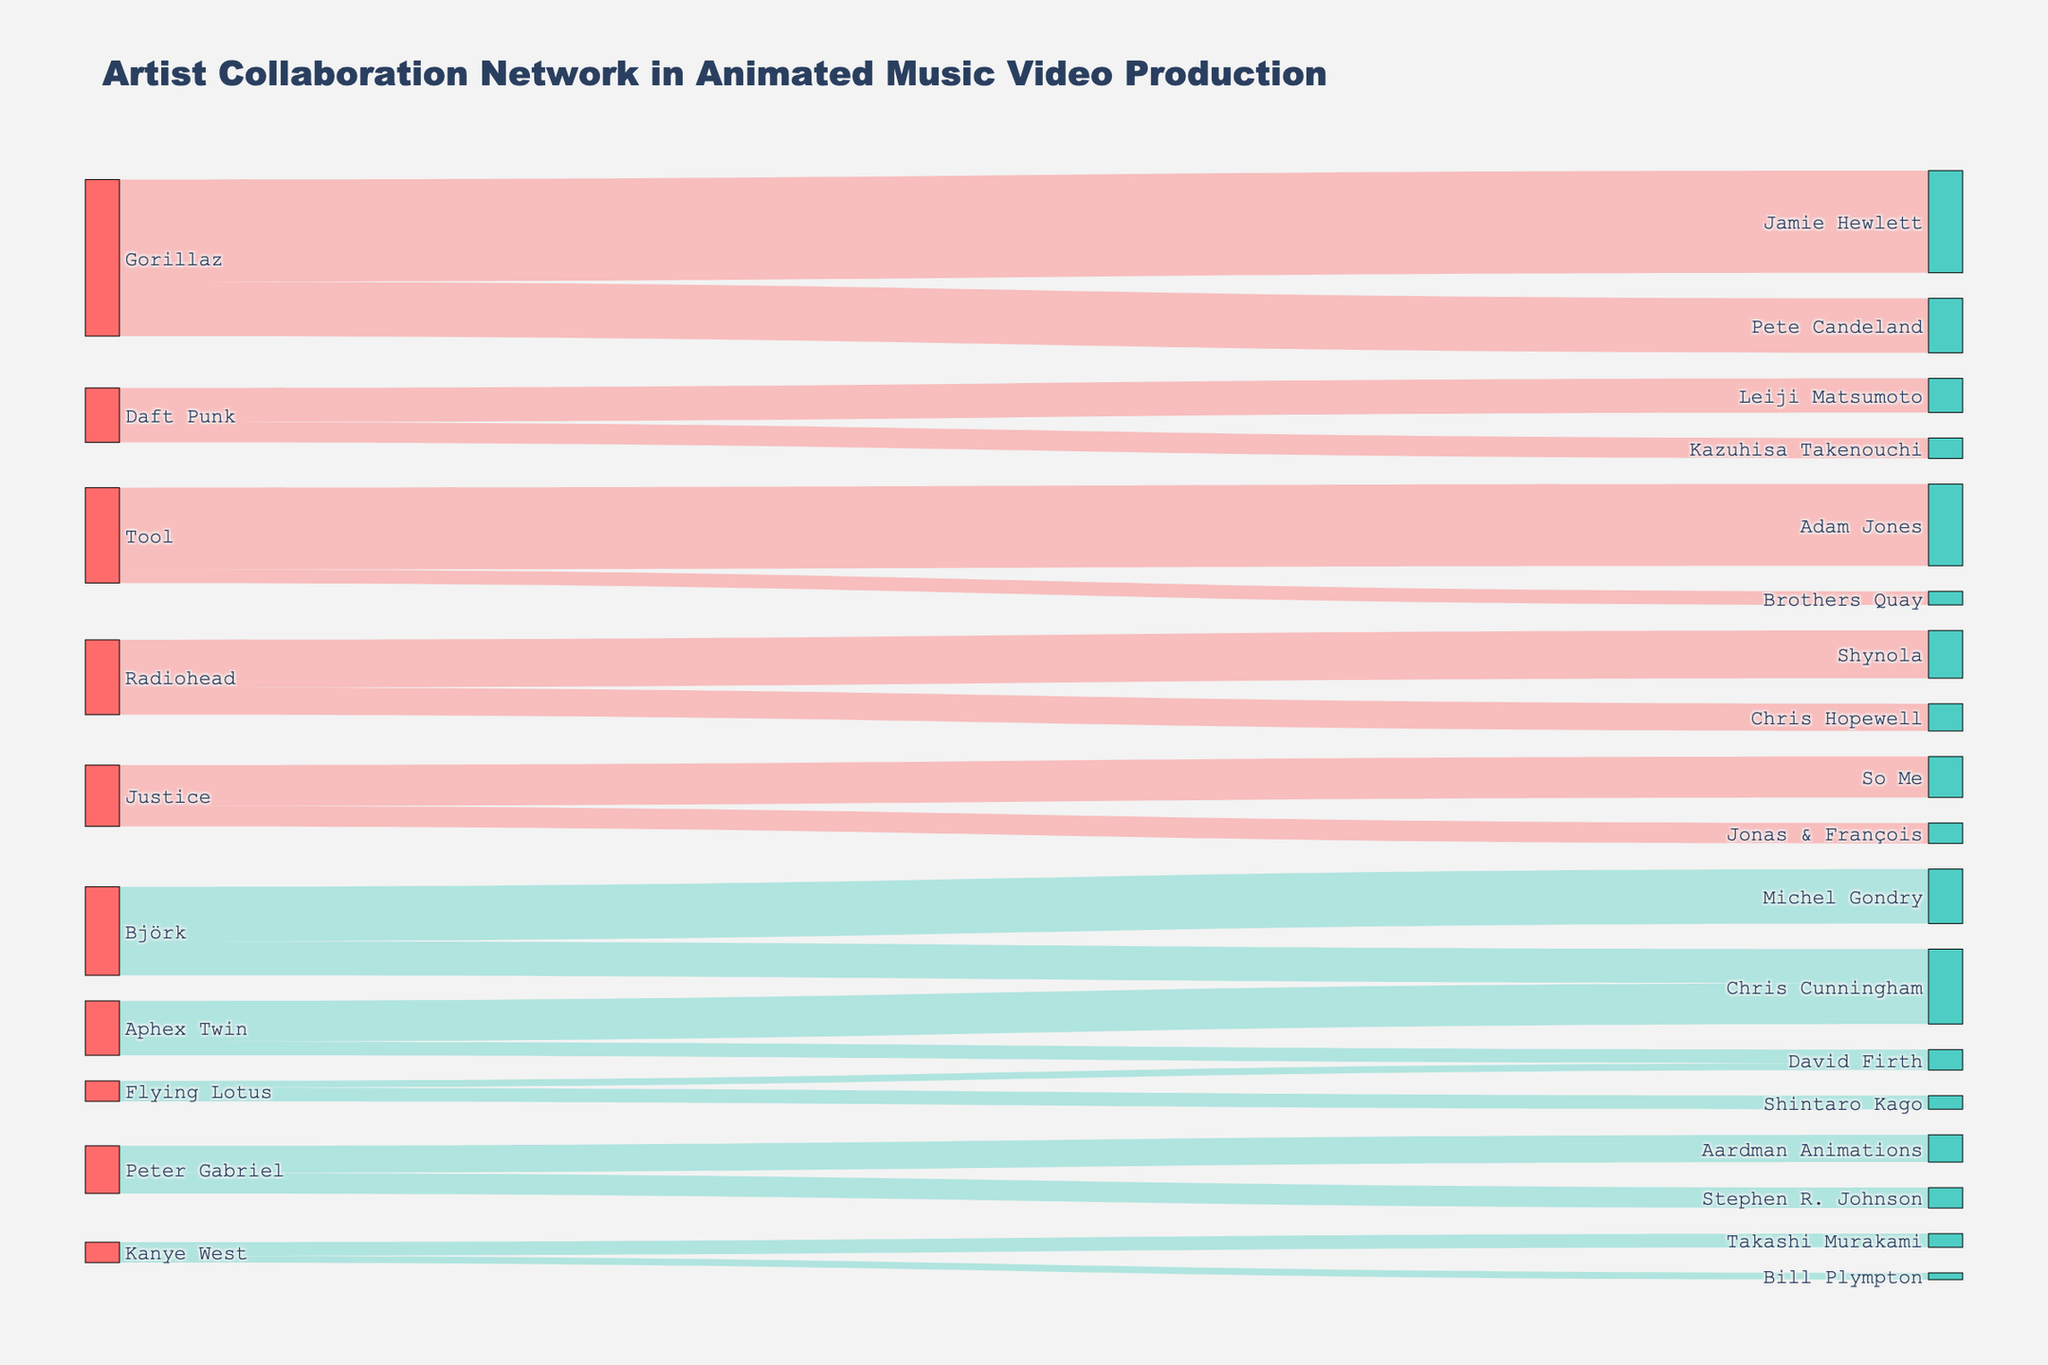How many collaborations does Gorillaz have in total? Gorillaz collaborates with Jamie Hewlett (15) and Pete Candeland (8). Adding these together gives 15 + 8 = 23.
Answer: 23 Which artist collaborates with Adam Jones? Adam Jones collaborates with the artist Tool, as shown by the connecting link between Tool and Adam Jones.
Answer: Tool Which artist has the highest collaboration value with Jamie Hewlett? Since Jamie Hewlett only collaborates with Gorillaz, the highest (and only) value is 15.
Answer: Gorillaz Sum of collaboration values between Radiohead and their collaborators? Radiohead collaborates with Shynola (7) and Chris Hopewell (4). Their total sum is 7 + 4 = 11.
Answer: 11 Who has more collaborations with Chris Cunningham: Aphex Twin or Björk? Aphex Twin collaborates with Chris Cunningham with a value of 6, while Björk collaborates with Chris Cunningham with a value of 5. Thus, Aphex Twin has more collaborations.
Answer: Aphex Twin Which artist collaborates with the most unique producers? Most unique producers can be found by comparing the number of different producers each artist collaborates with. Gorillaz (2), Daft Punk (2), Tool (2), Radiohead (2), Justice (2), Flying Lotus (2), Björk (2), Peter Gabriel (2), Kanye West (2), Aphex Twin (2). Since each artist collaborates with 2 producers, no single artist collaborates with more unique producers.
Answer: Tie among all artists What is the combined total of collaborations for artists with Aardman Animations and Takashi Murakami? Peter Gabriel collaborates with Aardman Animations (4) and Kanye West collaborates with Takashi Murakami (2). Combining these gives 4 + 2 = 6.
Answer: 6 Between Daft Punk and Aphex Twin, who collaborates more with their respective secondary producers? Daft Punk collaborates with Kazuhisa Takenouchi (3) and Aphex Twin collaborates with David Firth (2). Daft Punk's secondary collaboration is higher.
Answer: Daft Punk What is the average number of collaborations for the two artists who collaborate with David Firth? David Firth collaborates with Flying Lotus (1) and Aphex Twin (2). The average is (1 + 2) / 2 = 1.5.
Answer: 1.5 Identify which collaborations have the smallest value. The smallest value is 1, seen in the collaborations of Flying Lotus with David Firth and Kanye West with Bill Plympton.
Answer: Flying Lotus and David Firth, Kanye West and Bill Plympton 